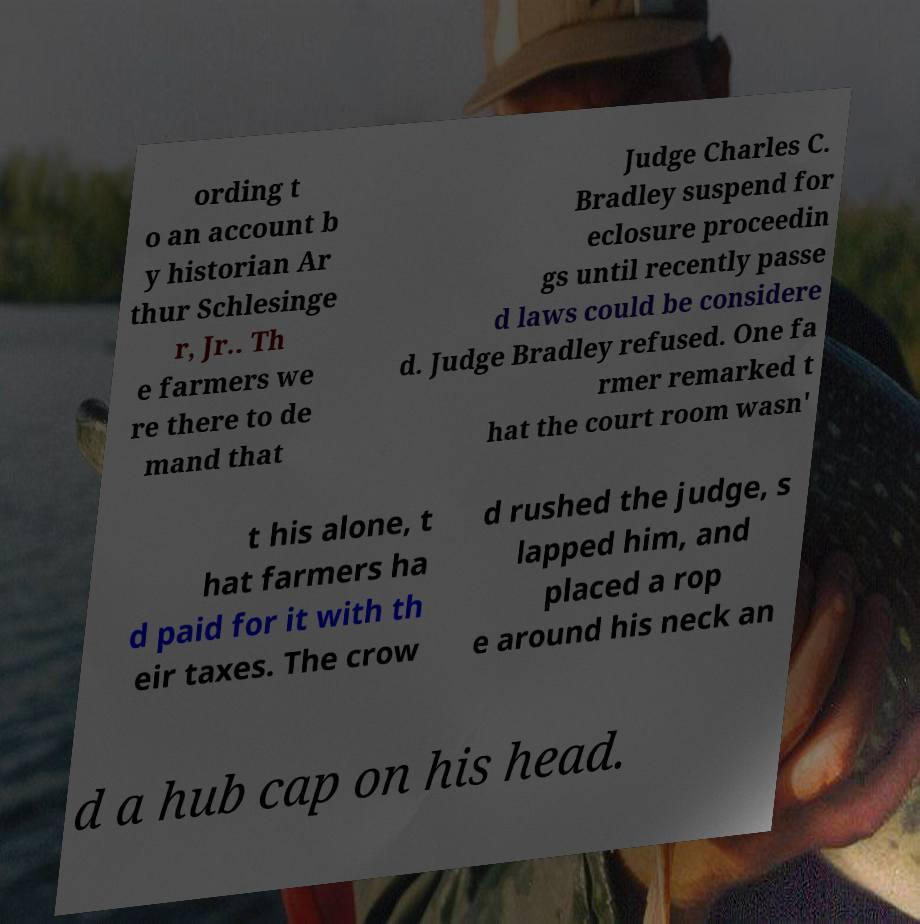What messages or text are displayed in this image? I need them in a readable, typed format. ording t o an account b y historian Ar thur Schlesinge r, Jr.. Th e farmers we re there to de mand that Judge Charles C. Bradley suspend for eclosure proceedin gs until recently passe d laws could be considere d. Judge Bradley refused. One fa rmer remarked t hat the court room wasn' t his alone, t hat farmers ha d paid for it with th eir taxes. The crow d rushed the judge, s lapped him, and placed a rop e around his neck an d a hub cap on his head. 